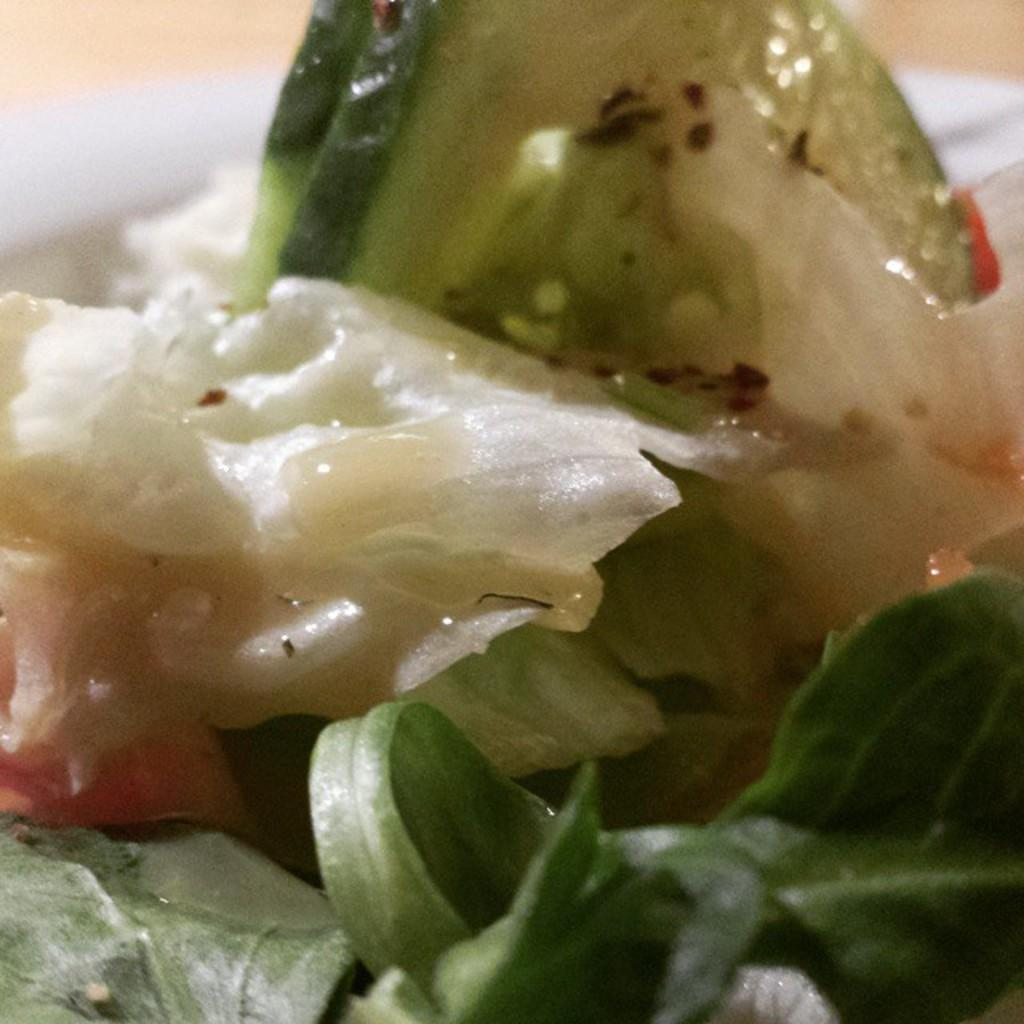What type of vegetable is present in the image? There is broccoli in the image. What other type of plant can be seen in the image? There are herbs in the image. What type of engine can be seen powering the broccoli in the image? There is no engine present in the image, and the broccoli is not being powered by any engine. Is there any rain visible in the image? There is no rain present in the image; it is focused on the broccoli and herbs. 